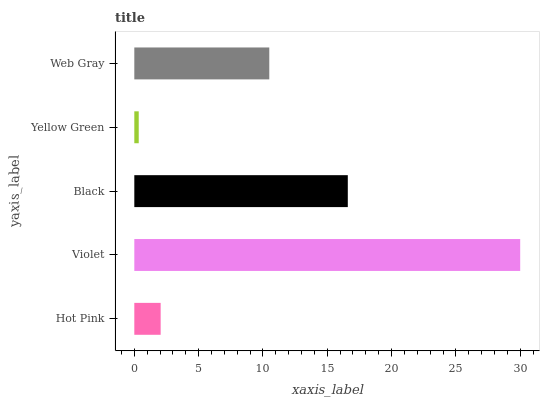Is Yellow Green the minimum?
Answer yes or no. Yes. Is Violet the maximum?
Answer yes or no. Yes. Is Black the minimum?
Answer yes or no. No. Is Black the maximum?
Answer yes or no. No. Is Violet greater than Black?
Answer yes or no. Yes. Is Black less than Violet?
Answer yes or no. Yes. Is Black greater than Violet?
Answer yes or no. No. Is Violet less than Black?
Answer yes or no. No. Is Web Gray the high median?
Answer yes or no. Yes. Is Web Gray the low median?
Answer yes or no. Yes. Is Hot Pink the high median?
Answer yes or no. No. Is Black the low median?
Answer yes or no. No. 